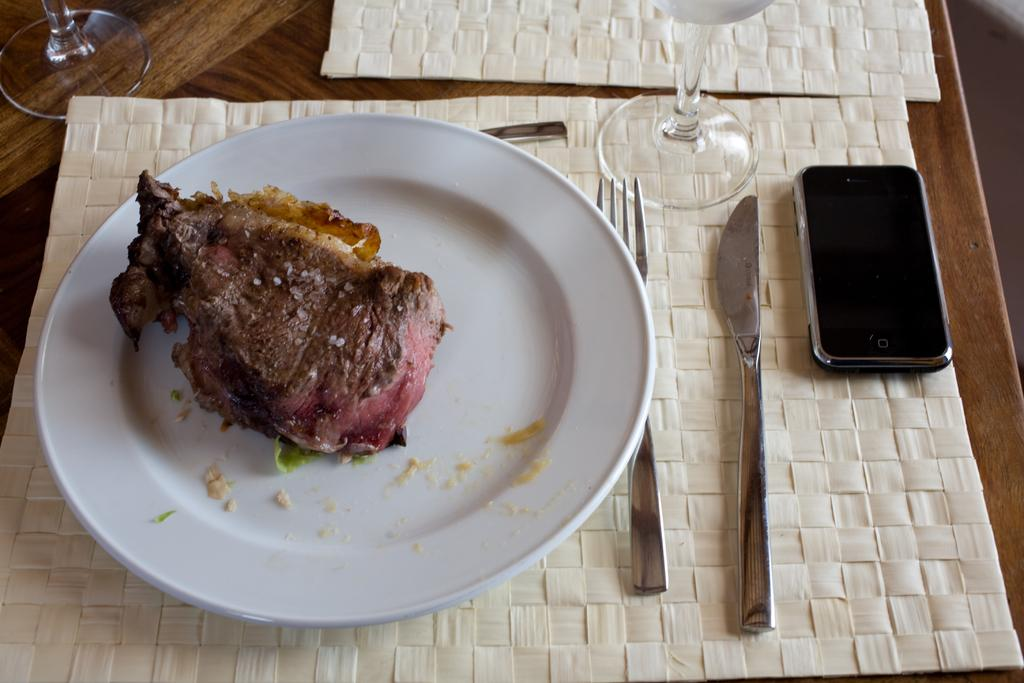What piece of furniture is present in the image? There is a table in the image. What is on the table? A plate containing food, a fork, a knife, a glass, and a mobile phone are on the table. What might be used for cutting in the image? There is a knife on the table that can be used for cutting. What might be used for drinking in the image? There is a glass on the table that can be used for drinking. What type of volleyball game is being played in the image? There is no volleyball game present in the image; it features a table with various items on it. What sound can be heard in the image due to the thunder? There is no thunder present in the image, so no such sound can be heard. 